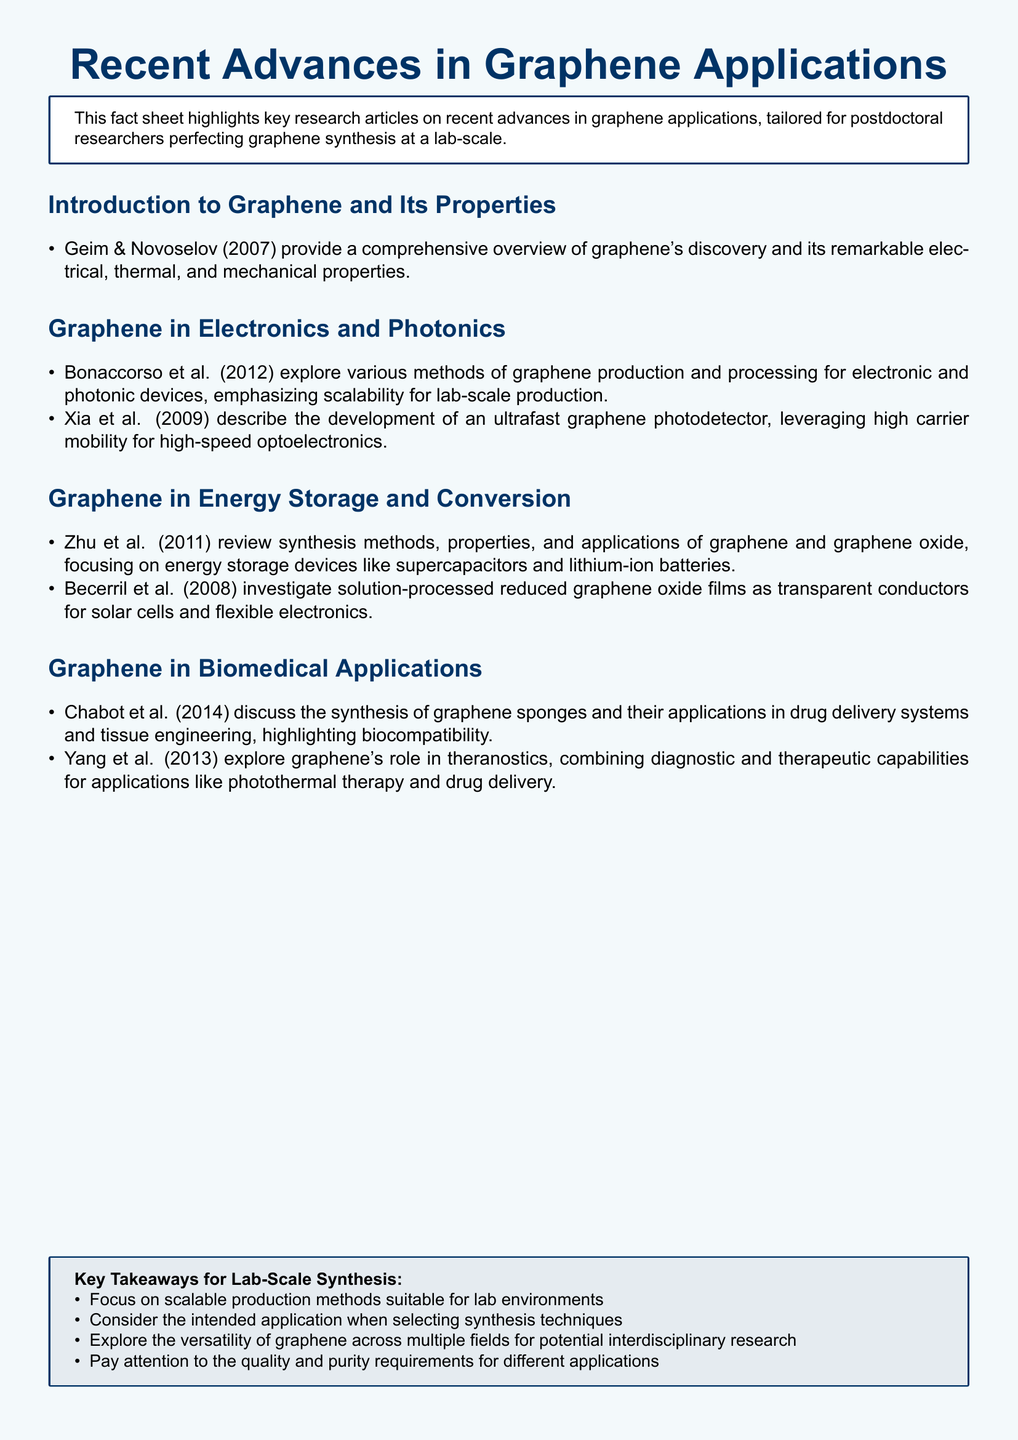what year did Geim and Novoselov publish their overview of graphene? Geim and Novoselov's work was published in 2007, which is mentioned in the introduction section of the document.
Answer: 2007 who explored the synthesis of graphene sponges? Chabot et al. are identified in the biomedical applications section as discussing the synthesis of graphene sponges.
Answer: Chabot et al which applications does Zhu et al. focus on regarding graphene? Zhu et al. review applications of graphene in energy storage devices such as supercapacitors and lithium-ion batteries, as stated in the energy storage section.
Answer: energy storage devices what is the purpose of the highlighted key takeaways? The key takeaways provide guidance on lab-scale synthesis of graphene, emphasizing production methods and quality requirements.
Answer: guidance on lab-scale synthesis how many articles are listed under Graphene in Electronics and Photonics? There are two articles listed under that section: Bonaccorso et al. (2012) and Xia et al. (2009), found in the respective section.
Answer: two articles what are the two main roles of graphene discussed by Yang et al.? Yang et al. explore the roles of graphene in diagnostics and therapeutics, as noted in the biomedical applications section.
Answer: diagnostics and therapeutics who reviewed the properties and applications of graphene oxide? Zhu et al. (2011) are the authors mentioned who review the properties and applications of graphene oxide.
Answer: Zhu et al what is the color scheme used in the fact sheet's background? The background color of the fact sheet is a light blue, specified at the beginning of the document.
Answer: light blue 